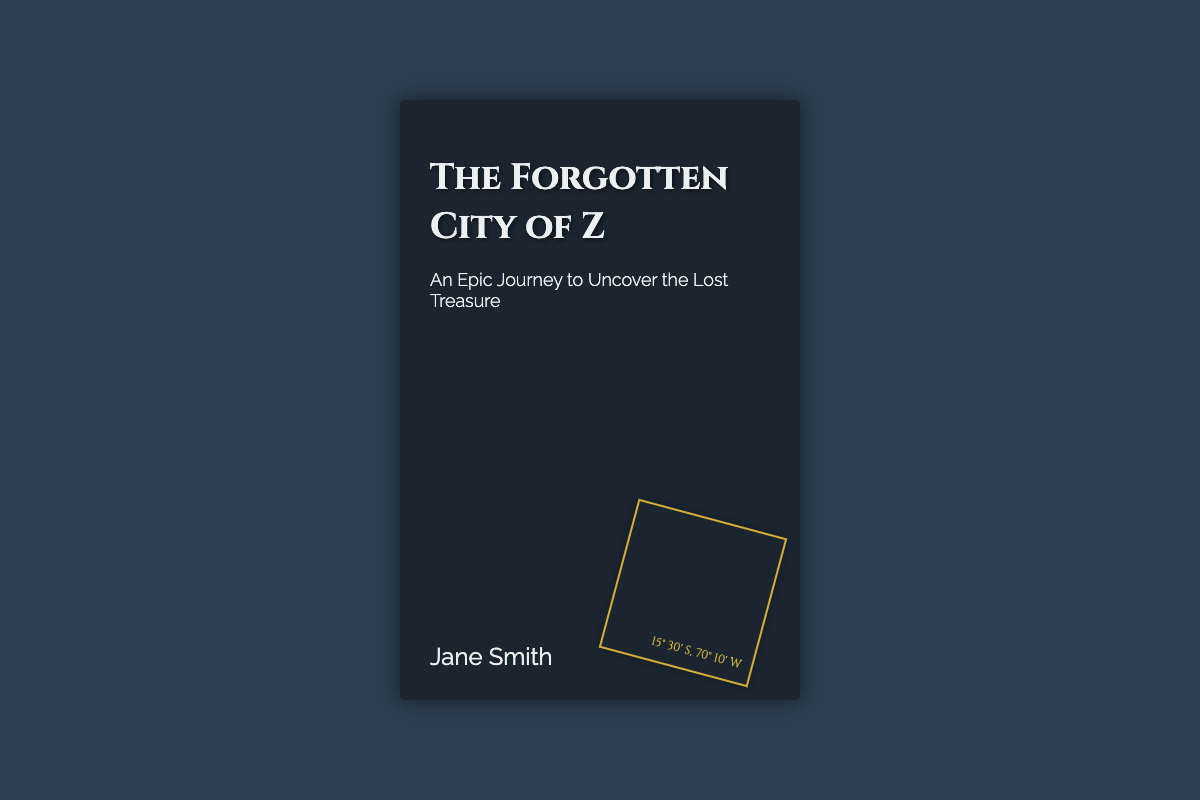What is the title of the book? The title of the book is prominently displayed at the top of the cover.
Answer: The Forgotten City of Z Who is the author of the book? The author's name is located at the bottom of the cover.
Answer: Jane Smith What is depicted in the background of the cover? The background features a lush jungle with ancient structures.
Answer: Jungle setting What does the subtitle describe? The subtitle provides insight into the theme or premise of the book.
Answer: An Epic Journey to Uncover the Lost Treasure What are the coordinates shown on the map fragment? The coordinates are listed near the bottom of the map fragment in the cover design.
Answer: 15° 30' S, 70° 10' W How many elements are highlighted in the title section? The title section includes the title, subtitle, and author name, which comprise three elements.
Answer: Three What design element adds atmosphere over the cover? The transparency layer over the cover enhances the visual depth.
Answer: Vines What is the shape of the map fragment? The map fragment is styled as a rotated square box.
Answer: Square How is the title text styled on the cover? The title text is styled in a larger, serif font with a shadow effect.
Answer: Serif font 